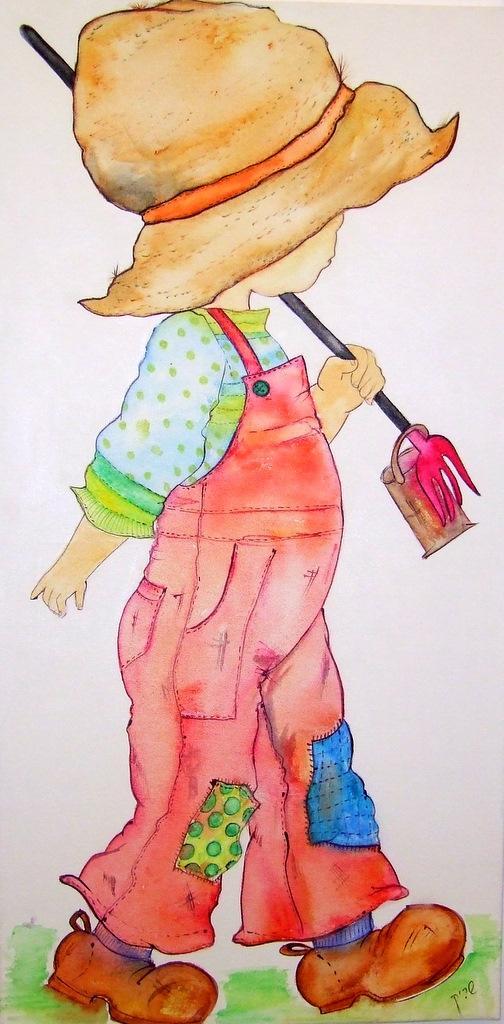How would you summarize this image in a sentence or two? In this picture we can see a painting. 